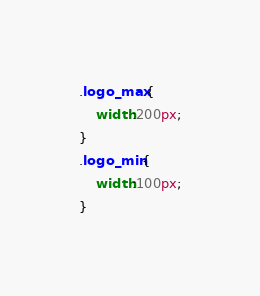Convert code to text. <code><loc_0><loc_0><loc_500><loc_500><_CSS_>.logo_max{    
    width:200px;
}
.logo_min{
    width:100px;
}</code> 